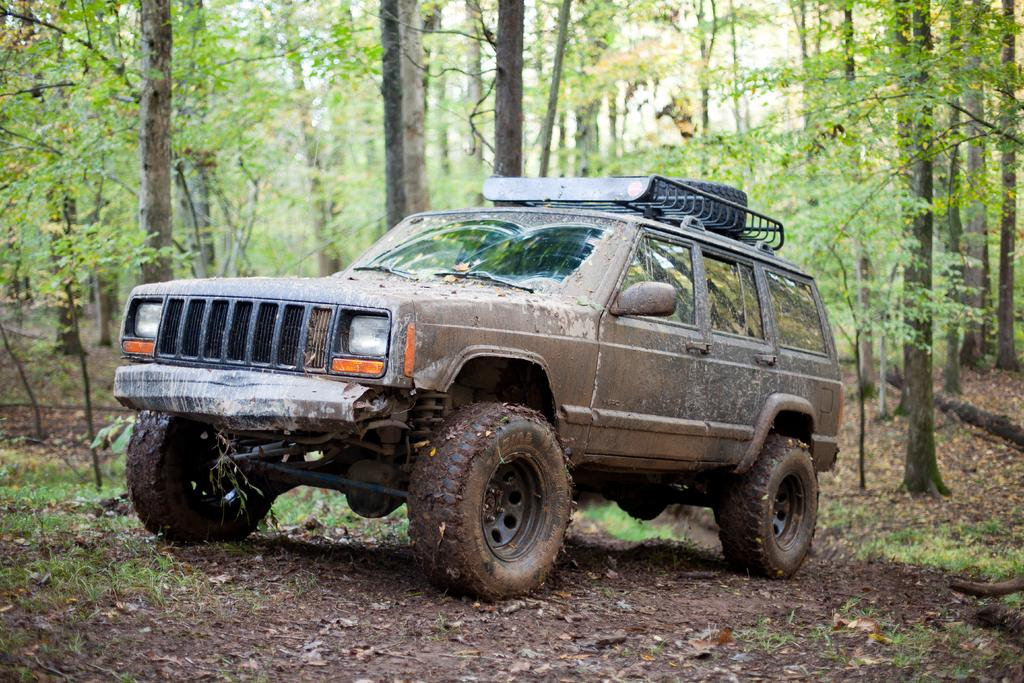What is the main subject of the image? There is a vehicle in the image. What colors can be seen on the vehicle? The vehicle is brown, black, and orange in color. Where is the vehicle located in the image? The vehicle is on the ground. What type of terrain is visible in the image? There is ground visible in the image. What natural elements can be seen in the image? There are trees and the sky visible in the image. Can you see any ants carrying a request in the image? There are no ants or requests present in the image. How many ants can be seen on the vehicle in the image? There are no ants visible on the vehicle or anywhere else in the image. 